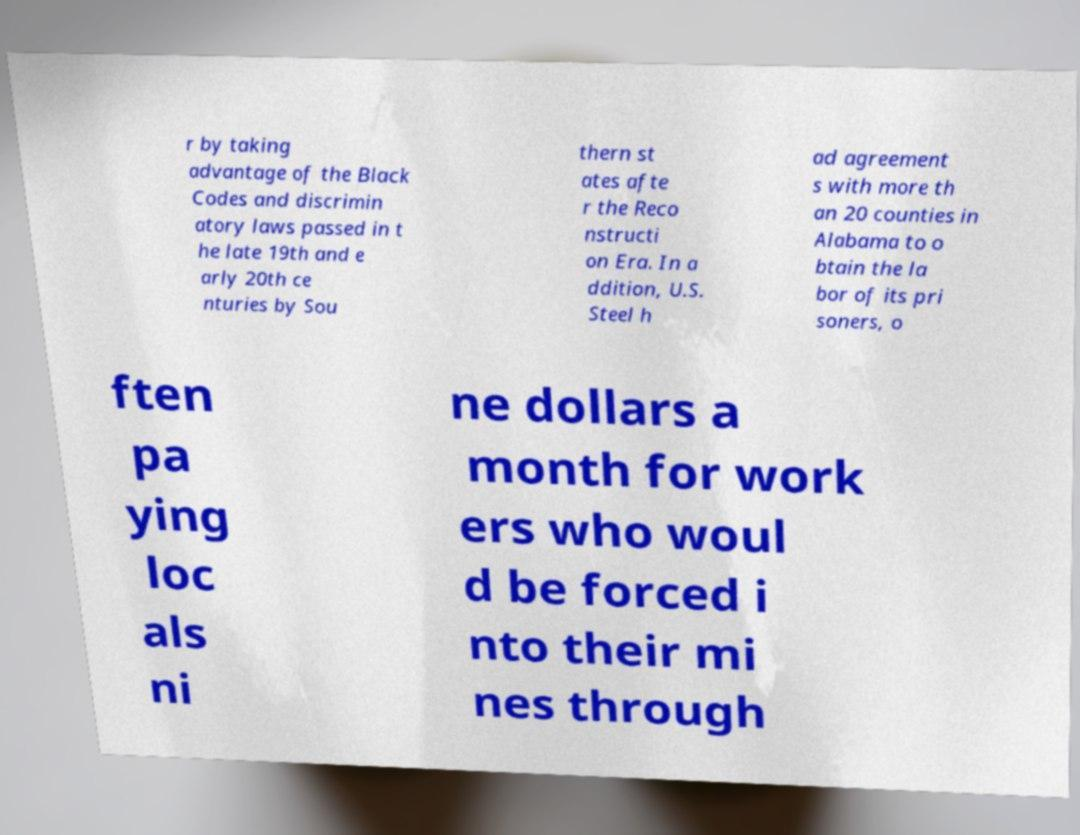Could you extract and type out the text from this image? r by taking advantage of the Black Codes and discrimin atory laws passed in t he late 19th and e arly 20th ce nturies by Sou thern st ates afte r the Reco nstructi on Era. In a ddition, U.S. Steel h ad agreement s with more th an 20 counties in Alabama to o btain the la bor of its pri soners, o ften pa ying loc als ni ne dollars a month for work ers who woul d be forced i nto their mi nes through 